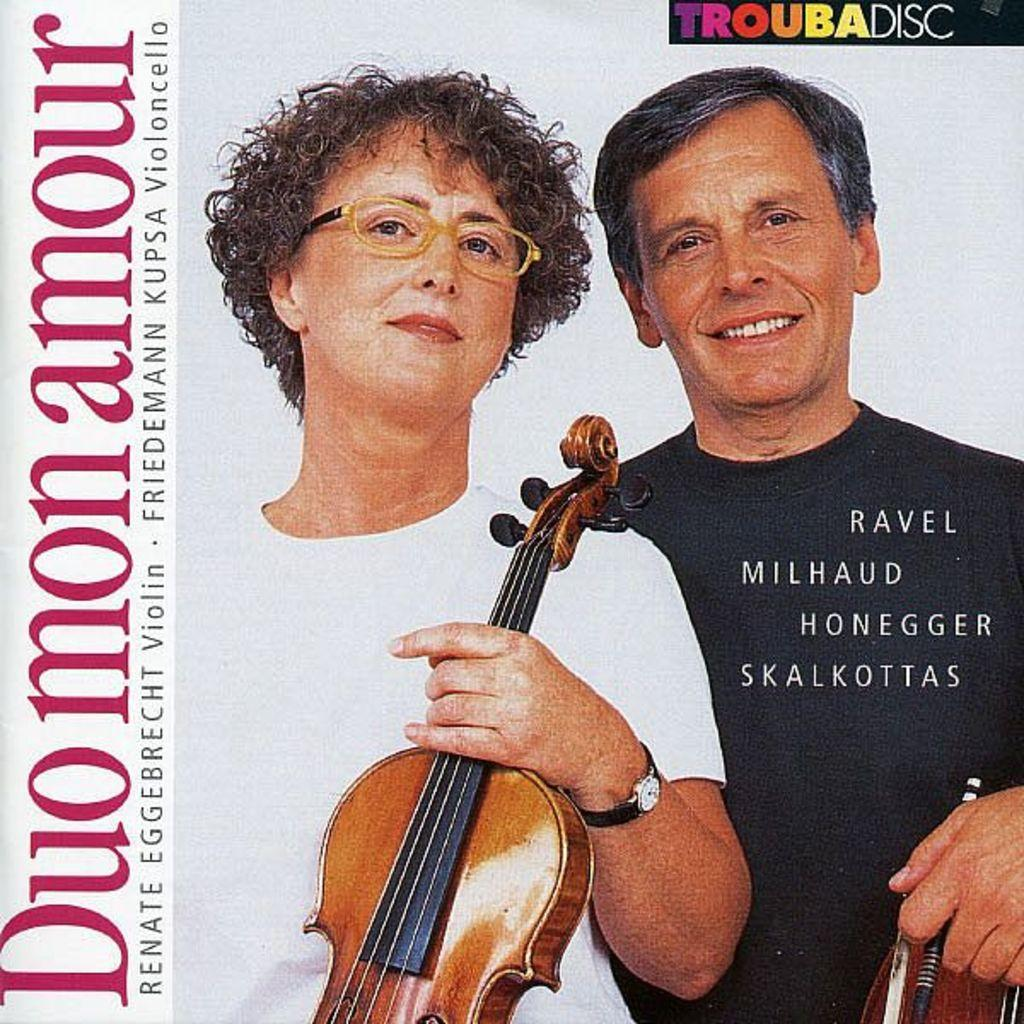What is featured on the banner in the image? There is a banner in the image, and two people holding guitars are depicted on it. What type of clam is being used as a decoration on the banner? There are no clams present on the banner; it features two people holding guitars. How much salt is sprinkled on the shirts of the people holding guitars? There are no shirts or salt mentioned in the image; it only features a banner with two people holding guitars. 